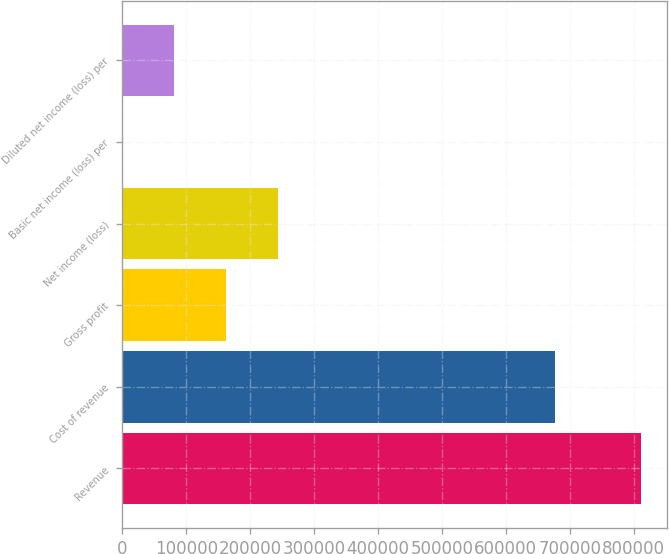Convert chart. <chart><loc_0><loc_0><loc_500><loc_500><bar_chart><fcel>Revenue<fcel>Cost of revenue<fcel>Gross profit<fcel>Net income (loss)<fcel>Basic net income (loss) per<fcel>Diluted net income (loss) per<nl><fcel>811208<fcel>676916<fcel>162242<fcel>243363<fcel>0.25<fcel>81121<nl></chart> 